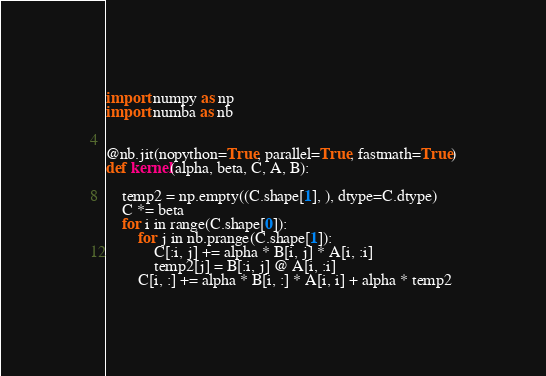Convert code to text. <code><loc_0><loc_0><loc_500><loc_500><_Python_>import numpy as np
import numba as nb


@nb.jit(nopython=True, parallel=True, fastmath=True)
def kernel(alpha, beta, C, A, B):

    temp2 = np.empty((C.shape[1], ), dtype=C.dtype)
    C *= beta
    for i in range(C.shape[0]):
        for j in nb.prange(C.shape[1]):
            C[:i, j] += alpha * B[i, j] * A[i, :i]
            temp2[j] = B[:i, j] @ A[i, :i]
        C[i, :] += alpha * B[i, :] * A[i, i] + alpha * temp2
</code> 